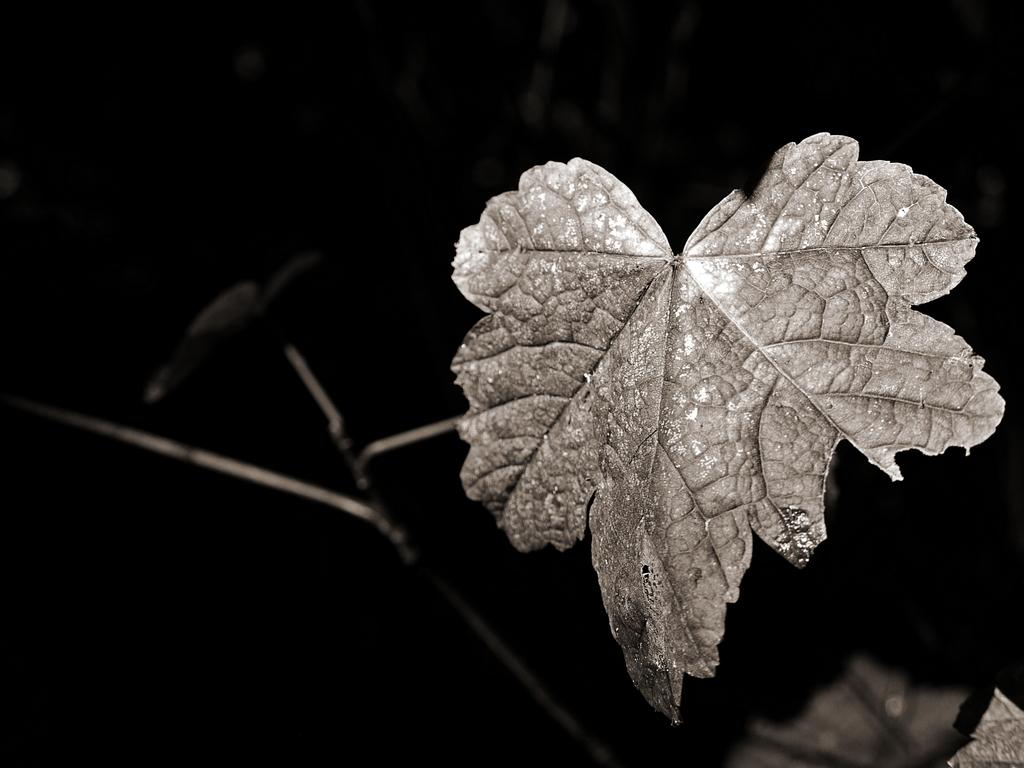What is the color scheme of the image? The image is black and white. What object can be seen in the image? There is a leaf in the image. How would you describe the background of the image? The background of the image is dark. How many straws are visible on the floor in the image? There are no straws visible on the floor in the image, as the facts provided do not mention any straws or a floor. 